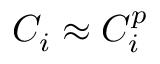<formula> <loc_0><loc_0><loc_500><loc_500>C _ { i } \approx C _ { i } ^ { p }</formula> 